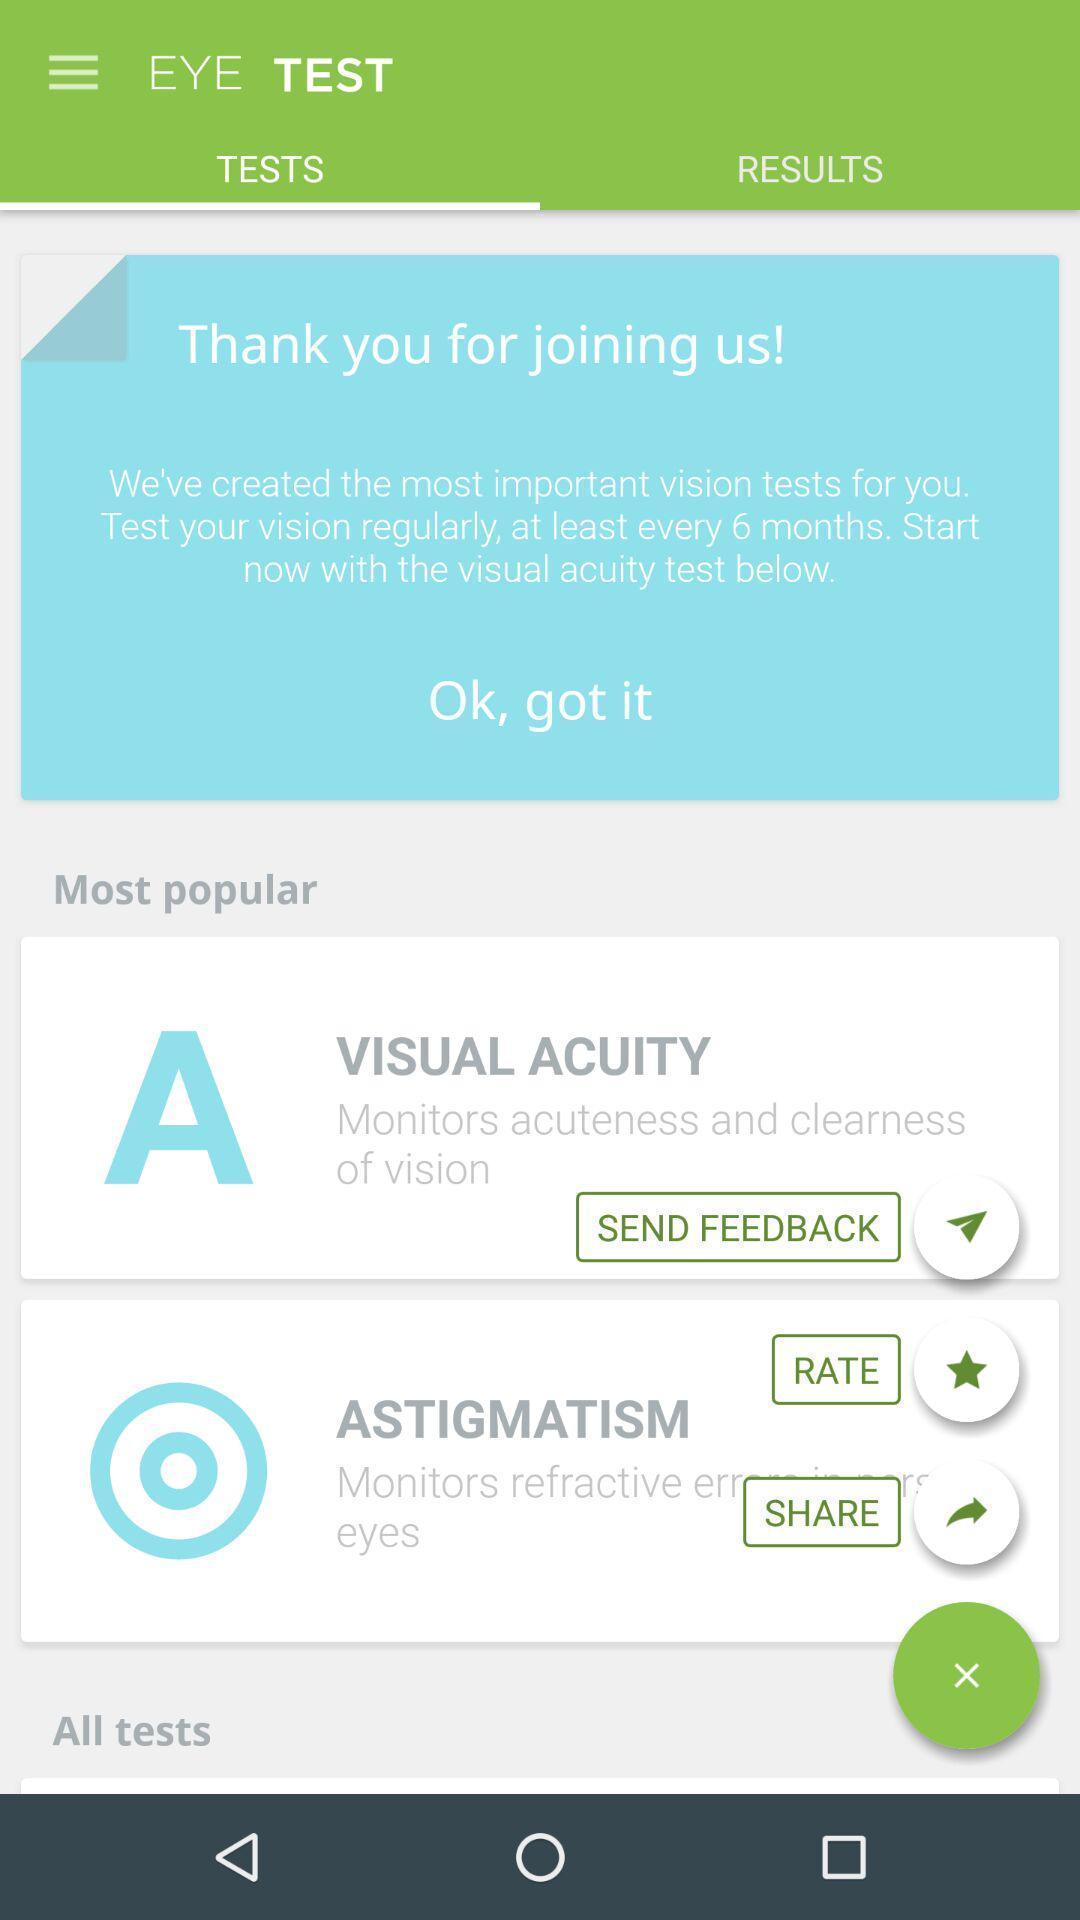What is the overall content of this screenshot? Screen page displaying various options in health application. 